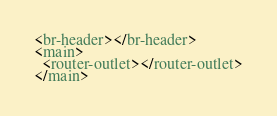<code> <loc_0><loc_0><loc_500><loc_500><_HTML_><br-header></br-header>
<main>
  <router-outlet></router-outlet>
</main>
</code> 